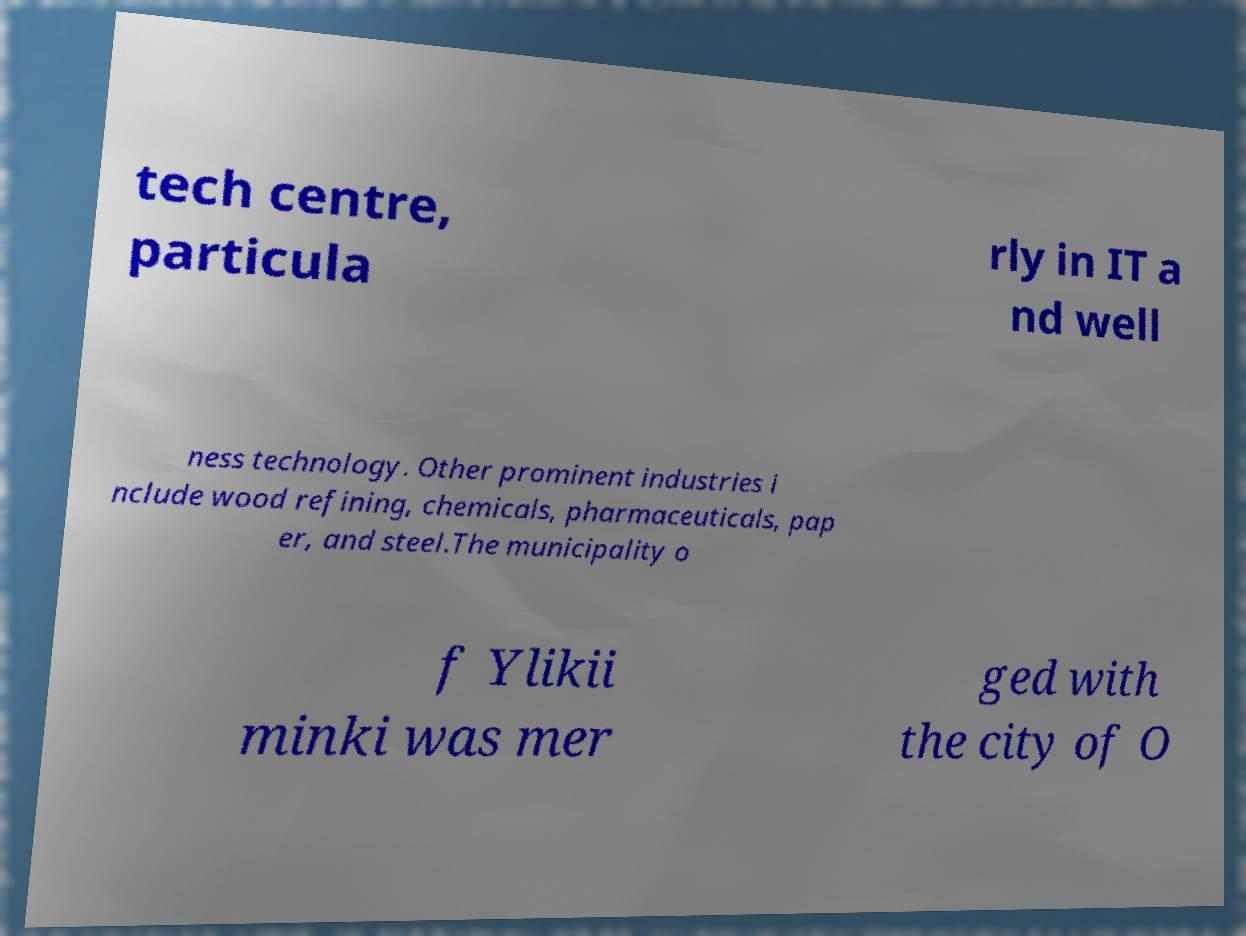Could you assist in decoding the text presented in this image and type it out clearly? tech centre, particula rly in IT a nd well ness technology. Other prominent industries i nclude wood refining, chemicals, pharmaceuticals, pap er, and steel.The municipality o f Ylikii minki was mer ged with the city of O 